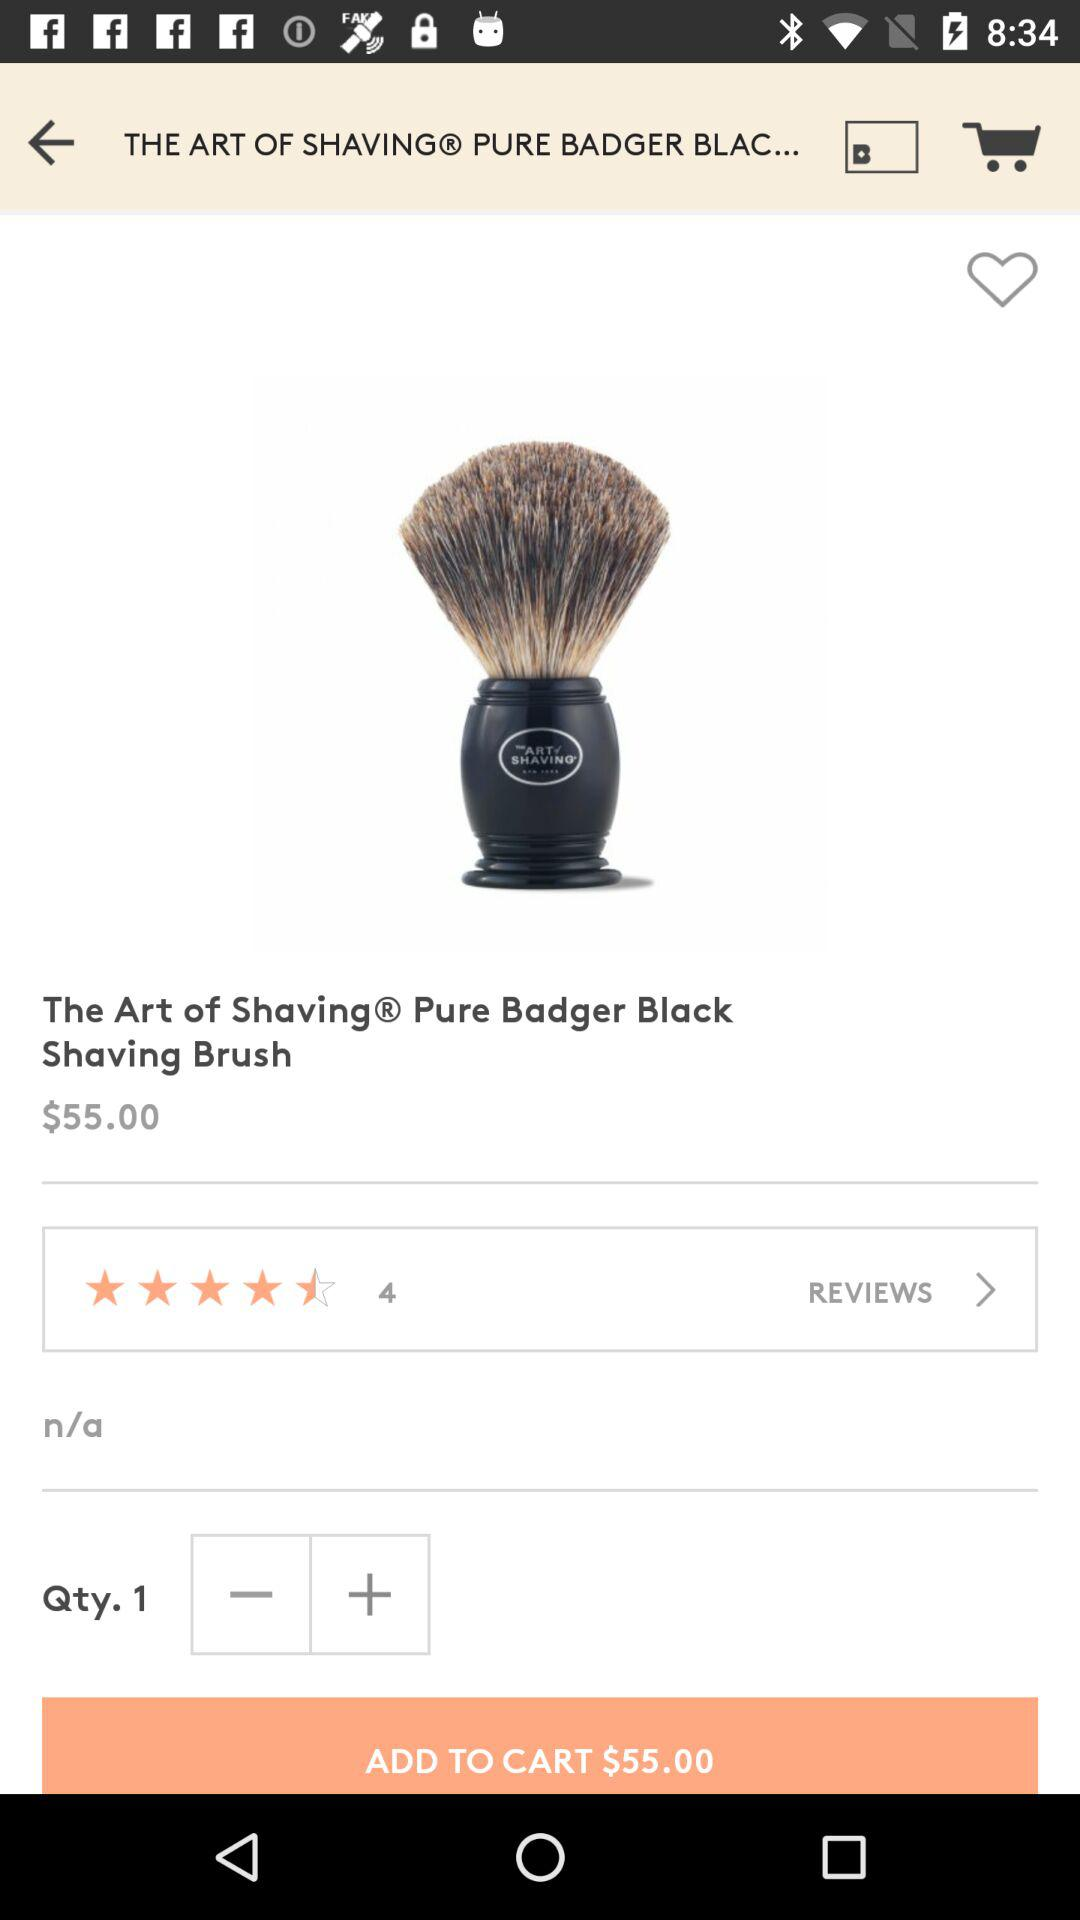What is the name of the item shown on the screen? The name of the item is The Art of Shaving Pure Badger Black Shaving Brush. 